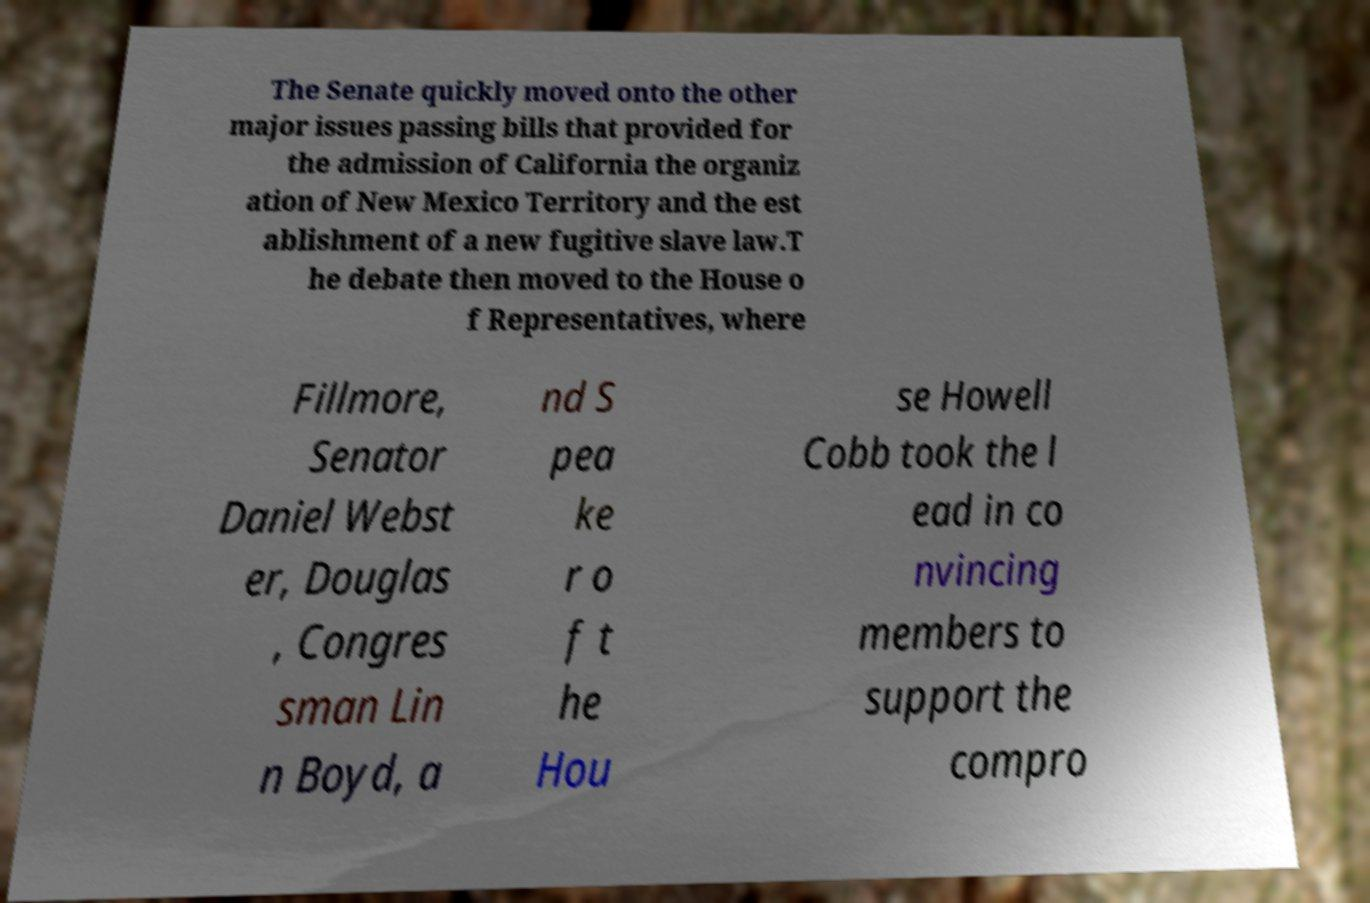Can you read and provide the text displayed in the image?This photo seems to have some interesting text. Can you extract and type it out for me? The Senate quickly moved onto the other major issues passing bills that provided for the admission of California the organiz ation of New Mexico Territory and the est ablishment of a new fugitive slave law.T he debate then moved to the House o f Representatives, where Fillmore, Senator Daniel Webst er, Douglas , Congres sman Lin n Boyd, a nd S pea ke r o f t he Hou se Howell Cobb took the l ead in co nvincing members to support the compro 